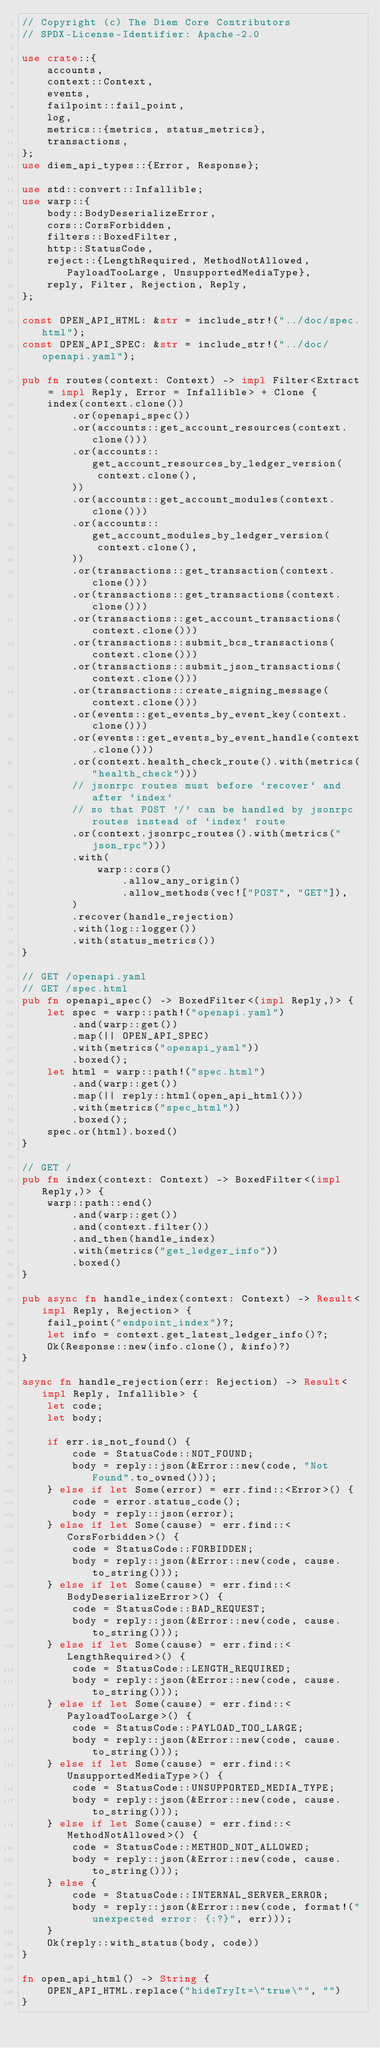Convert code to text. <code><loc_0><loc_0><loc_500><loc_500><_Rust_>// Copyright (c) The Diem Core Contributors
// SPDX-License-Identifier: Apache-2.0

use crate::{
    accounts,
    context::Context,
    events,
    failpoint::fail_point,
    log,
    metrics::{metrics, status_metrics},
    transactions,
};
use diem_api_types::{Error, Response};

use std::convert::Infallible;
use warp::{
    body::BodyDeserializeError,
    cors::CorsForbidden,
    filters::BoxedFilter,
    http::StatusCode,
    reject::{LengthRequired, MethodNotAllowed, PayloadTooLarge, UnsupportedMediaType},
    reply, Filter, Rejection, Reply,
};

const OPEN_API_HTML: &str = include_str!("../doc/spec.html");
const OPEN_API_SPEC: &str = include_str!("../doc/openapi.yaml");

pub fn routes(context: Context) -> impl Filter<Extract = impl Reply, Error = Infallible> + Clone {
    index(context.clone())
        .or(openapi_spec())
        .or(accounts::get_account_resources(context.clone()))
        .or(accounts::get_account_resources_by_ledger_version(
            context.clone(),
        ))
        .or(accounts::get_account_modules(context.clone()))
        .or(accounts::get_account_modules_by_ledger_version(
            context.clone(),
        ))
        .or(transactions::get_transaction(context.clone()))
        .or(transactions::get_transactions(context.clone()))
        .or(transactions::get_account_transactions(context.clone()))
        .or(transactions::submit_bcs_transactions(context.clone()))
        .or(transactions::submit_json_transactions(context.clone()))
        .or(transactions::create_signing_message(context.clone()))
        .or(events::get_events_by_event_key(context.clone()))
        .or(events::get_events_by_event_handle(context.clone()))
        .or(context.health_check_route().with(metrics("health_check")))
        // jsonrpc routes must before `recover` and after `index`
        // so that POST '/' can be handled by jsonrpc routes instead of `index` route
        .or(context.jsonrpc_routes().with(metrics("json_rpc")))
        .with(
            warp::cors()
                .allow_any_origin()
                .allow_methods(vec!["POST", "GET"]),
        )
        .recover(handle_rejection)
        .with(log::logger())
        .with(status_metrics())
}

// GET /openapi.yaml
// GET /spec.html
pub fn openapi_spec() -> BoxedFilter<(impl Reply,)> {
    let spec = warp::path!("openapi.yaml")
        .and(warp::get())
        .map(|| OPEN_API_SPEC)
        .with(metrics("openapi_yaml"))
        .boxed();
    let html = warp::path!("spec.html")
        .and(warp::get())
        .map(|| reply::html(open_api_html()))
        .with(metrics("spec_html"))
        .boxed();
    spec.or(html).boxed()
}

// GET /
pub fn index(context: Context) -> BoxedFilter<(impl Reply,)> {
    warp::path::end()
        .and(warp::get())
        .and(context.filter())
        .and_then(handle_index)
        .with(metrics("get_ledger_info"))
        .boxed()
}

pub async fn handle_index(context: Context) -> Result<impl Reply, Rejection> {
    fail_point("endpoint_index")?;
    let info = context.get_latest_ledger_info()?;
    Ok(Response::new(info.clone(), &info)?)
}

async fn handle_rejection(err: Rejection) -> Result<impl Reply, Infallible> {
    let code;
    let body;

    if err.is_not_found() {
        code = StatusCode::NOT_FOUND;
        body = reply::json(&Error::new(code, "Not Found".to_owned()));
    } else if let Some(error) = err.find::<Error>() {
        code = error.status_code();
        body = reply::json(error);
    } else if let Some(cause) = err.find::<CorsForbidden>() {
        code = StatusCode::FORBIDDEN;
        body = reply::json(&Error::new(code, cause.to_string()));
    } else if let Some(cause) = err.find::<BodyDeserializeError>() {
        code = StatusCode::BAD_REQUEST;
        body = reply::json(&Error::new(code, cause.to_string()));
    } else if let Some(cause) = err.find::<LengthRequired>() {
        code = StatusCode::LENGTH_REQUIRED;
        body = reply::json(&Error::new(code, cause.to_string()));
    } else if let Some(cause) = err.find::<PayloadTooLarge>() {
        code = StatusCode::PAYLOAD_TOO_LARGE;
        body = reply::json(&Error::new(code, cause.to_string()));
    } else if let Some(cause) = err.find::<UnsupportedMediaType>() {
        code = StatusCode::UNSUPPORTED_MEDIA_TYPE;
        body = reply::json(&Error::new(code, cause.to_string()));
    } else if let Some(cause) = err.find::<MethodNotAllowed>() {
        code = StatusCode::METHOD_NOT_ALLOWED;
        body = reply::json(&Error::new(code, cause.to_string()));
    } else {
        code = StatusCode::INTERNAL_SERVER_ERROR;
        body = reply::json(&Error::new(code, format!("unexpected error: {:?}", err)));
    }
    Ok(reply::with_status(body, code))
}

fn open_api_html() -> String {
    OPEN_API_HTML.replace("hideTryIt=\"true\"", "")
}
</code> 